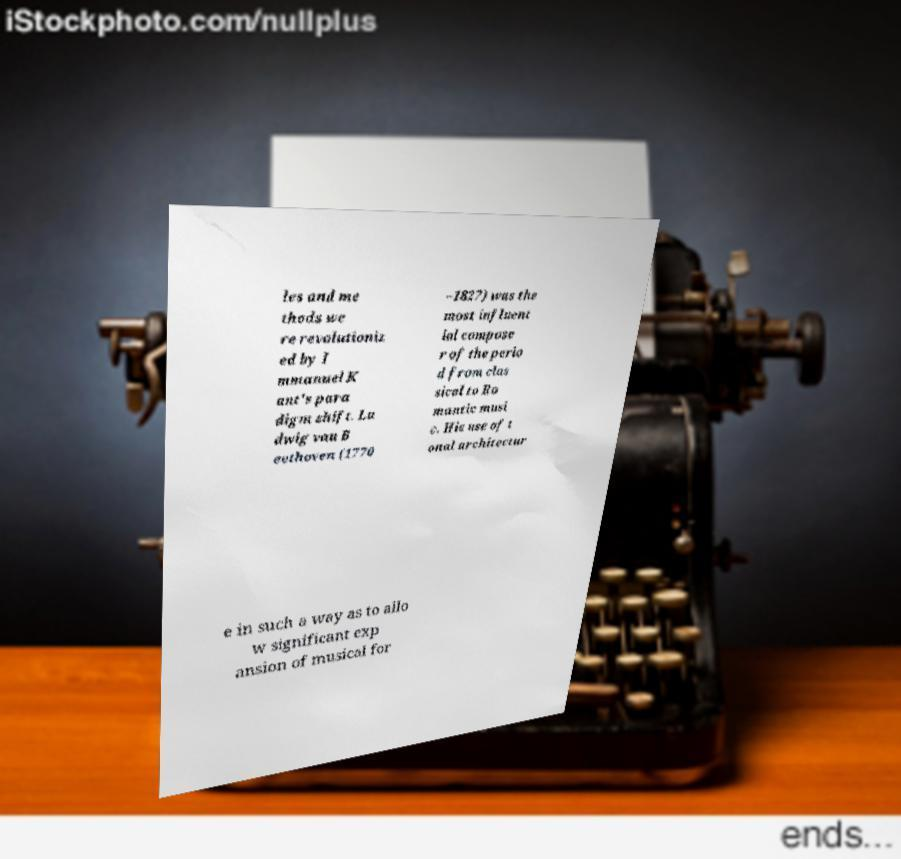I need the written content from this picture converted into text. Can you do that? les and me thods we re revolutioniz ed by I mmanuel K ant's para digm shift. Lu dwig van B eethoven (1770 –1827) was the most influent ial compose r of the perio d from clas sical to Ro mantic musi c. His use of t onal architectur e in such a way as to allo w significant exp ansion of musical for 